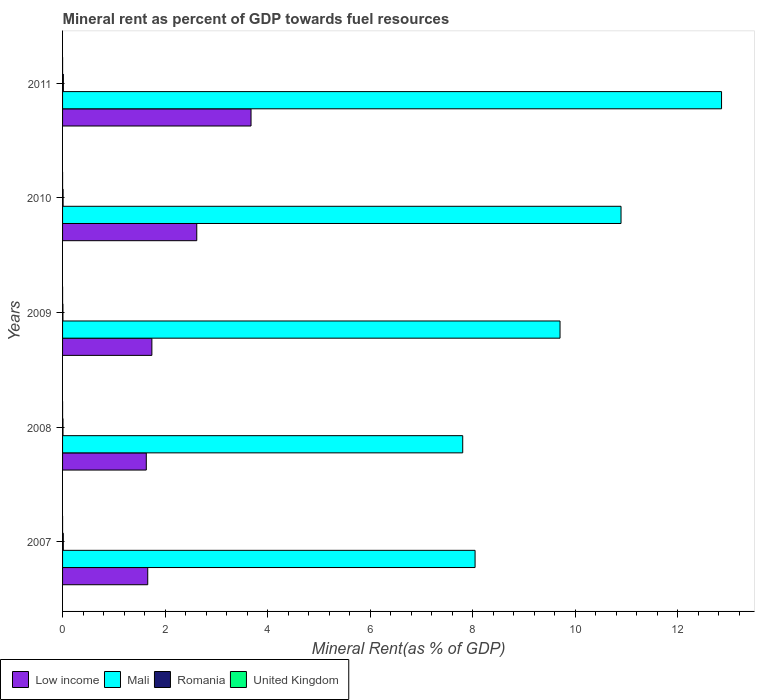How many different coloured bars are there?
Offer a terse response. 4. Are the number of bars on each tick of the Y-axis equal?
Keep it short and to the point. Yes. How many bars are there on the 5th tick from the bottom?
Your answer should be compact. 4. What is the label of the 3rd group of bars from the top?
Offer a terse response. 2009. What is the mineral rent in Low income in 2008?
Ensure brevity in your answer.  1.63. Across all years, what is the maximum mineral rent in Mali?
Keep it short and to the point. 12.86. Across all years, what is the minimum mineral rent in Low income?
Keep it short and to the point. 1.63. In which year was the mineral rent in Romania maximum?
Provide a short and direct response. 2011. What is the total mineral rent in Romania in the graph?
Your answer should be very brief. 0.06. What is the difference between the mineral rent in Romania in 2008 and that in 2011?
Your answer should be compact. -0.01. What is the difference between the mineral rent in Low income in 2010 and the mineral rent in Mali in 2011?
Give a very brief answer. -10.24. What is the average mineral rent in Romania per year?
Provide a succinct answer. 0.01. In the year 2009, what is the difference between the mineral rent in Romania and mineral rent in Mali?
Offer a very short reply. -9.7. What is the ratio of the mineral rent in Romania in 2010 to that in 2011?
Provide a succinct answer. 0.67. What is the difference between the highest and the second highest mineral rent in Mali?
Give a very brief answer. 1.96. What is the difference between the highest and the lowest mineral rent in Mali?
Keep it short and to the point. 5.05. Is the sum of the mineral rent in Low income in 2010 and 2011 greater than the maximum mineral rent in Mali across all years?
Ensure brevity in your answer.  No. What does the 2nd bar from the top in 2010 represents?
Keep it short and to the point. Romania. What does the 3rd bar from the bottom in 2010 represents?
Keep it short and to the point. Romania. Is it the case that in every year, the sum of the mineral rent in Mali and mineral rent in Romania is greater than the mineral rent in Low income?
Provide a short and direct response. Yes. Are all the bars in the graph horizontal?
Offer a very short reply. Yes. How many years are there in the graph?
Ensure brevity in your answer.  5. Does the graph contain any zero values?
Provide a succinct answer. No. Where does the legend appear in the graph?
Keep it short and to the point. Bottom left. How many legend labels are there?
Give a very brief answer. 4. What is the title of the graph?
Provide a succinct answer. Mineral rent as percent of GDP towards fuel resources. What is the label or title of the X-axis?
Provide a succinct answer. Mineral Rent(as % of GDP). What is the Mineral Rent(as % of GDP) of Low income in 2007?
Make the answer very short. 1.66. What is the Mineral Rent(as % of GDP) of Mali in 2007?
Offer a very short reply. 8.05. What is the Mineral Rent(as % of GDP) in Romania in 2007?
Give a very brief answer. 0.01. What is the Mineral Rent(as % of GDP) in United Kingdom in 2007?
Your answer should be compact. 3.21125777650235e-5. What is the Mineral Rent(as % of GDP) of Low income in 2008?
Make the answer very short. 1.63. What is the Mineral Rent(as % of GDP) of Mali in 2008?
Your response must be concise. 7.81. What is the Mineral Rent(as % of GDP) in Romania in 2008?
Your answer should be very brief. 0.01. What is the Mineral Rent(as % of GDP) of United Kingdom in 2008?
Your response must be concise. 0. What is the Mineral Rent(as % of GDP) of Low income in 2009?
Make the answer very short. 1.74. What is the Mineral Rent(as % of GDP) in Mali in 2009?
Your response must be concise. 9.71. What is the Mineral Rent(as % of GDP) in Romania in 2009?
Your response must be concise. 0.01. What is the Mineral Rent(as % of GDP) in United Kingdom in 2009?
Offer a very short reply. 0. What is the Mineral Rent(as % of GDP) of Low income in 2010?
Keep it short and to the point. 2.62. What is the Mineral Rent(as % of GDP) in Mali in 2010?
Offer a terse response. 10.9. What is the Mineral Rent(as % of GDP) of Romania in 2010?
Give a very brief answer. 0.01. What is the Mineral Rent(as % of GDP) of United Kingdom in 2010?
Offer a terse response. 0. What is the Mineral Rent(as % of GDP) of Low income in 2011?
Ensure brevity in your answer.  3.68. What is the Mineral Rent(as % of GDP) of Mali in 2011?
Your answer should be very brief. 12.86. What is the Mineral Rent(as % of GDP) in Romania in 2011?
Give a very brief answer. 0.02. What is the Mineral Rent(as % of GDP) of United Kingdom in 2011?
Keep it short and to the point. 0. Across all years, what is the maximum Mineral Rent(as % of GDP) in Low income?
Offer a very short reply. 3.68. Across all years, what is the maximum Mineral Rent(as % of GDP) of Mali?
Offer a very short reply. 12.86. Across all years, what is the maximum Mineral Rent(as % of GDP) of Romania?
Ensure brevity in your answer.  0.02. Across all years, what is the maximum Mineral Rent(as % of GDP) in United Kingdom?
Your response must be concise. 0. Across all years, what is the minimum Mineral Rent(as % of GDP) of Low income?
Your answer should be very brief. 1.63. Across all years, what is the minimum Mineral Rent(as % of GDP) of Mali?
Provide a short and direct response. 7.81. Across all years, what is the minimum Mineral Rent(as % of GDP) of Romania?
Make the answer very short. 0.01. Across all years, what is the minimum Mineral Rent(as % of GDP) of United Kingdom?
Your answer should be compact. 3.21125777650235e-5. What is the total Mineral Rent(as % of GDP) in Low income in the graph?
Provide a succinct answer. 11.33. What is the total Mineral Rent(as % of GDP) of Mali in the graph?
Provide a short and direct response. 49.32. What is the total Mineral Rent(as % of GDP) in Romania in the graph?
Provide a short and direct response. 0.06. What is the total Mineral Rent(as % of GDP) of United Kingdom in the graph?
Offer a very short reply. 0. What is the difference between the Mineral Rent(as % of GDP) in Low income in 2007 and that in 2008?
Provide a short and direct response. 0.03. What is the difference between the Mineral Rent(as % of GDP) of Mali in 2007 and that in 2008?
Make the answer very short. 0.24. What is the difference between the Mineral Rent(as % of GDP) of Romania in 2007 and that in 2008?
Provide a succinct answer. 0.01. What is the difference between the Mineral Rent(as % of GDP) of United Kingdom in 2007 and that in 2008?
Your response must be concise. -0. What is the difference between the Mineral Rent(as % of GDP) in Low income in 2007 and that in 2009?
Provide a short and direct response. -0.08. What is the difference between the Mineral Rent(as % of GDP) in Mali in 2007 and that in 2009?
Provide a succinct answer. -1.66. What is the difference between the Mineral Rent(as % of GDP) in Romania in 2007 and that in 2009?
Give a very brief answer. 0.01. What is the difference between the Mineral Rent(as % of GDP) of United Kingdom in 2007 and that in 2009?
Give a very brief answer. -0. What is the difference between the Mineral Rent(as % of GDP) of Low income in 2007 and that in 2010?
Offer a very short reply. -0.96. What is the difference between the Mineral Rent(as % of GDP) in Mali in 2007 and that in 2010?
Give a very brief answer. -2.85. What is the difference between the Mineral Rent(as % of GDP) in Romania in 2007 and that in 2010?
Make the answer very short. 0. What is the difference between the Mineral Rent(as % of GDP) in United Kingdom in 2007 and that in 2010?
Provide a short and direct response. -0. What is the difference between the Mineral Rent(as % of GDP) of Low income in 2007 and that in 2011?
Provide a short and direct response. -2.02. What is the difference between the Mineral Rent(as % of GDP) in Mali in 2007 and that in 2011?
Ensure brevity in your answer.  -4.81. What is the difference between the Mineral Rent(as % of GDP) of Romania in 2007 and that in 2011?
Keep it short and to the point. -0. What is the difference between the Mineral Rent(as % of GDP) of United Kingdom in 2007 and that in 2011?
Offer a terse response. -0. What is the difference between the Mineral Rent(as % of GDP) in Low income in 2008 and that in 2009?
Keep it short and to the point. -0.11. What is the difference between the Mineral Rent(as % of GDP) in Mali in 2008 and that in 2009?
Your answer should be very brief. -1.9. What is the difference between the Mineral Rent(as % of GDP) in Romania in 2008 and that in 2009?
Offer a very short reply. 0. What is the difference between the Mineral Rent(as % of GDP) in United Kingdom in 2008 and that in 2009?
Give a very brief answer. -0. What is the difference between the Mineral Rent(as % of GDP) in Low income in 2008 and that in 2010?
Keep it short and to the point. -0.98. What is the difference between the Mineral Rent(as % of GDP) in Mali in 2008 and that in 2010?
Your answer should be very brief. -3.09. What is the difference between the Mineral Rent(as % of GDP) of Romania in 2008 and that in 2010?
Provide a short and direct response. -0. What is the difference between the Mineral Rent(as % of GDP) of United Kingdom in 2008 and that in 2010?
Offer a very short reply. -0. What is the difference between the Mineral Rent(as % of GDP) in Low income in 2008 and that in 2011?
Provide a succinct answer. -2.04. What is the difference between the Mineral Rent(as % of GDP) in Mali in 2008 and that in 2011?
Give a very brief answer. -5.05. What is the difference between the Mineral Rent(as % of GDP) in Romania in 2008 and that in 2011?
Keep it short and to the point. -0.01. What is the difference between the Mineral Rent(as % of GDP) in United Kingdom in 2008 and that in 2011?
Your response must be concise. -0. What is the difference between the Mineral Rent(as % of GDP) in Low income in 2009 and that in 2010?
Your answer should be very brief. -0.88. What is the difference between the Mineral Rent(as % of GDP) in Mali in 2009 and that in 2010?
Give a very brief answer. -1.19. What is the difference between the Mineral Rent(as % of GDP) of Romania in 2009 and that in 2010?
Your response must be concise. -0. What is the difference between the Mineral Rent(as % of GDP) of United Kingdom in 2009 and that in 2010?
Ensure brevity in your answer.  -0. What is the difference between the Mineral Rent(as % of GDP) of Low income in 2009 and that in 2011?
Give a very brief answer. -1.93. What is the difference between the Mineral Rent(as % of GDP) of Mali in 2009 and that in 2011?
Offer a terse response. -3.15. What is the difference between the Mineral Rent(as % of GDP) of Romania in 2009 and that in 2011?
Your answer should be very brief. -0.01. What is the difference between the Mineral Rent(as % of GDP) in United Kingdom in 2009 and that in 2011?
Keep it short and to the point. -0. What is the difference between the Mineral Rent(as % of GDP) of Low income in 2010 and that in 2011?
Provide a succinct answer. -1.06. What is the difference between the Mineral Rent(as % of GDP) in Mali in 2010 and that in 2011?
Your response must be concise. -1.96. What is the difference between the Mineral Rent(as % of GDP) of Romania in 2010 and that in 2011?
Offer a very short reply. -0.01. What is the difference between the Mineral Rent(as % of GDP) in United Kingdom in 2010 and that in 2011?
Offer a terse response. -0. What is the difference between the Mineral Rent(as % of GDP) of Low income in 2007 and the Mineral Rent(as % of GDP) of Mali in 2008?
Make the answer very short. -6.15. What is the difference between the Mineral Rent(as % of GDP) in Low income in 2007 and the Mineral Rent(as % of GDP) in Romania in 2008?
Your answer should be compact. 1.65. What is the difference between the Mineral Rent(as % of GDP) of Low income in 2007 and the Mineral Rent(as % of GDP) of United Kingdom in 2008?
Provide a short and direct response. 1.66. What is the difference between the Mineral Rent(as % of GDP) of Mali in 2007 and the Mineral Rent(as % of GDP) of Romania in 2008?
Provide a succinct answer. 8.04. What is the difference between the Mineral Rent(as % of GDP) in Mali in 2007 and the Mineral Rent(as % of GDP) in United Kingdom in 2008?
Provide a short and direct response. 8.05. What is the difference between the Mineral Rent(as % of GDP) in Romania in 2007 and the Mineral Rent(as % of GDP) in United Kingdom in 2008?
Offer a very short reply. 0.01. What is the difference between the Mineral Rent(as % of GDP) in Low income in 2007 and the Mineral Rent(as % of GDP) in Mali in 2009?
Ensure brevity in your answer.  -8.05. What is the difference between the Mineral Rent(as % of GDP) of Low income in 2007 and the Mineral Rent(as % of GDP) of Romania in 2009?
Your response must be concise. 1.65. What is the difference between the Mineral Rent(as % of GDP) of Low income in 2007 and the Mineral Rent(as % of GDP) of United Kingdom in 2009?
Ensure brevity in your answer.  1.66. What is the difference between the Mineral Rent(as % of GDP) of Mali in 2007 and the Mineral Rent(as % of GDP) of Romania in 2009?
Your answer should be compact. 8.04. What is the difference between the Mineral Rent(as % of GDP) in Mali in 2007 and the Mineral Rent(as % of GDP) in United Kingdom in 2009?
Ensure brevity in your answer.  8.05. What is the difference between the Mineral Rent(as % of GDP) in Romania in 2007 and the Mineral Rent(as % of GDP) in United Kingdom in 2009?
Make the answer very short. 0.01. What is the difference between the Mineral Rent(as % of GDP) of Low income in 2007 and the Mineral Rent(as % of GDP) of Mali in 2010?
Provide a succinct answer. -9.24. What is the difference between the Mineral Rent(as % of GDP) of Low income in 2007 and the Mineral Rent(as % of GDP) of Romania in 2010?
Provide a short and direct response. 1.65. What is the difference between the Mineral Rent(as % of GDP) in Low income in 2007 and the Mineral Rent(as % of GDP) in United Kingdom in 2010?
Make the answer very short. 1.66. What is the difference between the Mineral Rent(as % of GDP) of Mali in 2007 and the Mineral Rent(as % of GDP) of Romania in 2010?
Offer a terse response. 8.04. What is the difference between the Mineral Rent(as % of GDP) of Mali in 2007 and the Mineral Rent(as % of GDP) of United Kingdom in 2010?
Provide a succinct answer. 8.05. What is the difference between the Mineral Rent(as % of GDP) of Romania in 2007 and the Mineral Rent(as % of GDP) of United Kingdom in 2010?
Make the answer very short. 0.01. What is the difference between the Mineral Rent(as % of GDP) of Low income in 2007 and the Mineral Rent(as % of GDP) of Mali in 2011?
Offer a very short reply. -11.2. What is the difference between the Mineral Rent(as % of GDP) of Low income in 2007 and the Mineral Rent(as % of GDP) of Romania in 2011?
Offer a terse response. 1.65. What is the difference between the Mineral Rent(as % of GDP) in Low income in 2007 and the Mineral Rent(as % of GDP) in United Kingdom in 2011?
Offer a terse response. 1.66. What is the difference between the Mineral Rent(as % of GDP) in Mali in 2007 and the Mineral Rent(as % of GDP) in Romania in 2011?
Your response must be concise. 8.03. What is the difference between the Mineral Rent(as % of GDP) of Mali in 2007 and the Mineral Rent(as % of GDP) of United Kingdom in 2011?
Provide a short and direct response. 8.05. What is the difference between the Mineral Rent(as % of GDP) of Romania in 2007 and the Mineral Rent(as % of GDP) of United Kingdom in 2011?
Offer a terse response. 0.01. What is the difference between the Mineral Rent(as % of GDP) in Low income in 2008 and the Mineral Rent(as % of GDP) in Mali in 2009?
Give a very brief answer. -8.07. What is the difference between the Mineral Rent(as % of GDP) of Low income in 2008 and the Mineral Rent(as % of GDP) of Romania in 2009?
Give a very brief answer. 1.63. What is the difference between the Mineral Rent(as % of GDP) in Low income in 2008 and the Mineral Rent(as % of GDP) in United Kingdom in 2009?
Keep it short and to the point. 1.63. What is the difference between the Mineral Rent(as % of GDP) in Mali in 2008 and the Mineral Rent(as % of GDP) in Romania in 2009?
Provide a succinct answer. 7.8. What is the difference between the Mineral Rent(as % of GDP) in Mali in 2008 and the Mineral Rent(as % of GDP) in United Kingdom in 2009?
Offer a very short reply. 7.81. What is the difference between the Mineral Rent(as % of GDP) of Romania in 2008 and the Mineral Rent(as % of GDP) of United Kingdom in 2009?
Ensure brevity in your answer.  0.01. What is the difference between the Mineral Rent(as % of GDP) in Low income in 2008 and the Mineral Rent(as % of GDP) in Mali in 2010?
Offer a terse response. -9.26. What is the difference between the Mineral Rent(as % of GDP) of Low income in 2008 and the Mineral Rent(as % of GDP) of Romania in 2010?
Provide a succinct answer. 1.62. What is the difference between the Mineral Rent(as % of GDP) of Low income in 2008 and the Mineral Rent(as % of GDP) of United Kingdom in 2010?
Ensure brevity in your answer.  1.63. What is the difference between the Mineral Rent(as % of GDP) of Mali in 2008 and the Mineral Rent(as % of GDP) of Romania in 2010?
Your response must be concise. 7.8. What is the difference between the Mineral Rent(as % of GDP) of Mali in 2008 and the Mineral Rent(as % of GDP) of United Kingdom in 2010?
Provide a short and direct response. 7.81. What is the difference between the Mineral Rent(as % of GDP) of Romania in 2008 and the Mineral Rent(as % of GDP) of United Kingdom in 2010?
Offer a very short reply. 0.01. What is the difference between the Mineral Rent(as % of GDP) in Low income in 2008 and the Mineral Rent(as % of GDP) in Mali in 2011?
Make the answer very short. -11.22. What is the difference between the Mineral Rent(as % of GDP) in Low income in 2008 and the Mineral Rent(as % of GDP) in Romania in 2011?
Keep it short and to the point. 1.62. What is the difference between the Mineral Rent(as % of GDP) in Low income in 2008 and the Mineral Rent(as % of GDP) in United Kingdom in 2011?
Ensure brevity in your answer.  1.63. What is the difference between the Mineral Rent(as % of GDP) of Mali in 2008 and the Mineral Rent(as % of GDP) of Romania in 2011?
Make the answer very short. 7.79. What is the difference between the Mineral Rent(as % of GDP) in Mali in 2008 and the Mineral Rent(as % of GDP) in United Kingdom in 2011?
Give a very brief answer. 7.81. What is the difference between the Mineral Rent(as % of GDP) in Romania in 2008 and the Mineral Rent(as % of GDP) in United Kingdom in 2011?
Ensure brevity in your answer.  0.01. What is the difference between the Mineral Rent(as % of GDP) of Low income in 2009 and the Mineral Rent(as % of GDP) of Mali in 2010?
Your response must be concise. -9.15. What is the difference between the Mineral Rent(as % of GDP) in Low income in 2009 and the Mineral Rent(as % of GDP) in Romania in 2010?
Provide a short and direct response. 1.73. What is the difference between the Mineral Rent(as % of GDP) in Low income in 2009 and the Mineral Rent(as % of GDP) in United Kingdom in 2010?
Offer a terse response. 1.74. What is the difference between the Mineral Rent(as % of GDP) in Mali in 2009 and the Mineral Rent(as % of GDP) in Romania in 2010?
Provide a succinct answer. 9.7. What is the difference between the Mineral Rent(as % of GDP) in Mali in 2009 and the Mineral Rent(as % of GDP) in United Kingdom in 2010?
Offer a terse response. 9.71. What is the difference between the Mineral Rent(as % of GDP) in Romania in 2009 and the Mineral Rent(as % of GDP) in United Kingdom in 2010?
Offer a very short reply. 0.01. What is the difference between the Mineral Rent(as % of GDP) of Low income in 2009 and the Mineral Rent(as % of GDP) of Mali in 2011?
Ensure brevity in your answer.  -11.12. What is the difference between the Mineral Rent(as % of GDP) in Low income in 2009 and the Mineral Rent(as % of GDP) in Romania in 2011?
Your response must be concise. 1.73. What is the difference between the Mineral Rent(as % of GDP) of Low income in 2009 and the Mineral Rent(as % of GDP) of United Kingdom in 2011?
Your answer should be very brief. 1.74. What is the difference between the Mineral Rent(as % of GDP) in Mali in 2009 and the Mineral Rent(as % of GDP) in Romania in 2011?
Your answer should be very brief. 9.69. What is the difference between the Mineral Rent(as % of GDP) in Mali in 2009 and the Mineral Rent(as % of GDP) in United Kingdom in 2011?
Your answer should be compact. 9.71. What is the difference between the Mineral Rent(as % of GDP) of Romania in 2009 and the Mineral Rent(as % of GDP) of United Kingdom in 2011?
Your answer should be very brief. 0.01. What is the difference between the Mineral Rent(as % of GDP) in Low income in 2010 and the Mineral Rent(as % of GDP) in Mali in 2011?
Offer a very short reply. -10.24. What is the difference between the Mineral Rent(as % of GDP) in Low income in 2010 and the Mineral Rent(as % of GDP) in Romania in 2011?
Your answer should be compact. 2.6. What is the difference between the Mineral Rent(as % of GDP) in Low income in 2010 and the Mineral Rent(as % of GDP) in United Kingdom in 2011?
Provide a succinct answer. 2.62. What is the difference between the Mineral Rent(as % of GDP) in Mali in 2010 and the Mineral Rent(as % of GDP) in Romania in 2011?
Make the answer very short. 10.88. What is the difference between the Mineral Rent(as % of GDP) in Mali in 2010 and the Mineral Rent(as % of GDP) in United Kingdom in 2011?
Provide a short and direct response. 10.9. What is the difference between the Mineral Rent(as % of GDP) of Romania in 2010 and the Mineral Rent(as % of GDP) of United Kingdom in 2011?
Keep it short and to the point. 0.01. What is the average Mineral Rent(as % of GDP) of Low income per year?
Make the answer very short. 2.27. What is the average Mineral Rent(as % of GDP) in Mali per year?
Make the answer very short. 9.86. What is the average Mineral Rent(as % of GDP) in Romania per year?
Your response must be concise. 0.01. In the year 2007, what is the difference between the Mineral Rent(as % of GDP) in Low income and Mineral Rent(as % of GDP) in Mali?
Offer a terse response. -6.39. In the year 2007, what is the difference between the Mineral Rent(as % of GDP) of Low income and Mineral Rent(as % of GDP) of Romania?
Ensure brevity in your answer.  1.65. In the year 2007, what is the difference between the Mineral Rent(as % of GDP) in Low income and Mineral Rent(as % of GDP) in United Kingdom?
Offer a terse response. 1.66. In the year 2007, what is the difference between the Mineral Rent(as % of GDP) of Mali and Mineral Rent(as % of GDP) of Romania?
Offer a very short reply. 8.04. In the year 2007, what is the difference between the Mineral Rent(as % of GDP) in Mali and Mineral Rent(as % of GDP) in United Kingdom?
Keep it short and to the point. 8.05. In the year 2007, what is the difference between the Mineral Rent(as % of GDP) of Romania and Mineral Rent(as % of GDP) of United Kingdom?
Your answer should be very brief. 0.01. In the year 2008, what is the difference between the Mineral Rent(as % of GDP) in Low income and Mineral Rent(as % of GDP) in Mali?
Offer a terse response. -6.17. In the year 2008, what is the difference between the Mineral Rent(as % of GDP) of Low income and Mineral Rent(as % of GDP) of Romania?
Your answer should be compact. 1.63. In the year 2008, what is the difference between the Mineral Rent(as % of GDP) in Low income and Mineral Rent(as % of GDP) in United Kingdom?
Your answer should be compact. 1.63. In the year 2008, what is the difference between the Mineral Rent(as % of GDP) in Mali and Mineral Rent(as % of GDP) in Romania?
Offer a terse response. 7.8. In the year 2008, what is the difference between the Mineral Rent(as % of GDP) of Mali and Mineral Rent(as % of GDP) of United Kingdom?
Your answer should be very brief. 7.81. In the year 2008, what is the difference between the Mineral Rent(as % of GDP) of Romania and Mineral Rent(as % of GDP) of United Kingdom?
Keep it short and to the point. 0.01. In the year 2009, what is the difference between the Mineral Rent(as % of GDP) of Low income and Mineral Rent(as % of GDP) of Mali?
Your response must be concise. -7.96. In the year 2009, what is the difference between the Mineral Rent(as % of GDP) in Low income and Mineral Rent(as % of GDP) in Romania?
Keep it short and to the point. 1.74. In the year 2009, what is the difference between the Mineral Rent(as % of GDP) in Low income and Mineral Rent(as % of GDP) in United Kingdom?
Make the answer very short. 1.74. In the year 2009, what is the difference between the Mineral Rent(as % of GDP) in Mali and Mineral Rent(as % of GDP) in Romania?
Your response must be concise. 9.7. In the year 2009, what is the difference between the Mineral Rent(as % of GDP) of Mali and Mineral Rent(as % of GDP) of United Kingdom?
Ensure brevity in your answer.  9.71. In the year 2009, what is the difference between the Mineral Rent(as % of GDP) of Romania and Mineral Rent(as % of GDP) of United Kingdom?
Ensure brevity in your answer.  0.01. In the year 2010, what is the difference between the Mineral Rent(as % of GDP) in Low income and Mineral Rent(as % of GDP) in Mali?
Offer a terse response. -8.28. In the year 2010, what is the difference between the Mineral Rent(as % of GDP) in Low income and Mineral Rent(as % of GDP) in Romania?
Provide a succinct answer. 2.61. In the year 2010, what is the difference between the Mineral Rent(as % of GDP) in Low income and Mineral Rent(as % of GDP) in United Kingdom?
Make the answer very short. 2.62. In the year 2010, what is the difference between the Mineral Rent(as % of GDP) in Mali and Mineral Rent(as % of GDP) in Romania?
Give a very brief answer. 10.89. In the year 2010, what is the difference between the Mineral Rent(as % of GDP) in Mali and Mineral Rent(as % of GDP) in United Kingdom?
Ensure brevity in your answer.  10.9. In the year 2010, what is the difference between the Mineral Rent(as % of GDP) in Romania and Mineral Rent(as % of GDP) in United Kingdom?
Give a very brief answer. 0.01. In the year 2011, what is the difference between the Mineral Rent(as % of GDP) of Low income and Mineral Rent(as % of GDP) of Mali?
Make the answer very short. -9.18. In the year 2011, what is the difference between the Mineral Rent(as % of GDP) of Low income and Mineral Rent(as % of GDP) of Romania?
Keep it short and to the point. 3.66. In the year 2011, what is the difference between the Mineral Rent(as % of GDP) in Low income and Mineral Rent(as % of GDP) in United Kingdom?
Offer a terse response. 3.68. In the year 2011, what is the difference between the Mineral Rent(as % of GDP) of Mali and Mineral Rent(as % of GDP) of Romania?
Ensure brevity in your answer.  12.84. In the year 2011, what is the difference between the Mineral Rent(as % of GDP) of Mali and Mineral Rent(as % of GDP) of United Kingdom?
Offer a very short reply. 12.86. In the year 2011, what is the difference between the Mineral Rent(as % of GDP) in Romania and Mineral Rent(as % of GDP) in United Kingdom?
Provide a succinct answer. 0.02. What is the ratio of the Mineral Rent(as % of GDP) in Low income in 2007 to that in 2008?
Offer a very short reply. 1.02. What is the ratio of the Mineral Rent(as % of GDP) of Mali in 2007 to that in 2008?
Offer a very short reply. 1.03. What is the ratio of the Mineral Rent(as % of GDP) of Romania in 2007 to that in 2008?
Provide a succinct answer. 1.69. What is the ratio of the Mineral Rent(as % of GDP) of United Kingdom in 2007 to that in 2008?
Keep it short and to the point. 0.26. What is the ratio of the Mineral Rent(as % of GDP) of Low income in 2007 to that in 2009?
Offer a terse response. 0.95. What is the ratio of the Mineral Rent(as % of GDP) in Mali in 2007 to that in 2009?
Offer a terse response. 0.83. What is the ratio of the Mineral Rent(as % of GDP) in Romania in 2007 to that in 2009?
Keep it short and to the point. 1.99. What is the ratio of the Mineral Rent(as % of GDP) in United Kingdom in 2007 to that in 2009?
Ensure brevity in your answer.  0.17. What is the ratio of the Mineral Rent(as % of GDP) in Low income in 2007 to that in 2010?
Provide a short and direct response. 0.63. What is the ratio of the Mineral Rent(as % of GDP) in Mali in 2007 to that in 2010?
Make the answer very short. 0.74. What is the ratio of the Mineral Rent(as % of GDP) in Romania in 2007 to that in 2010?
Your answer should be very brief. 1.37. What is the ratio of the Mineral Rent(as % of GDP) of United Kingdom in 2007 to that in 2010?
Your response must be concise. 0.14. What is the ratio of the Mineral Rent(as % of GDP) of Low income in 2007 to that in 2011?
Provide a succinct answer. 0.45. What is the ratio of the Mineral Rent(as % of GDP) of Mali in 2007 to that in 2011?
Provide a succinct answer. 0.63. What is the ratio of the Mineral Rent(as % of GDP) in Romania in 2007 to that in 2011?
Offer a very short reply. 0.92. What is the ratio of the Mineral Rent(as % of GDP) in United Kingdom in 2007 to that in 2011?
Your answer should be very brief. 0.1. What is the ratio of the Mineral Rent(as % of GDP) of Mali in 2008 to that in 2009?
Your answer should be compact. 0.8. What is the ratio of the Mineral Rent(as % of GDP) in Romania in 2008 to that in 2009?
Give a very brief answer. 1.17. What is the ratio of the Mineral Rent(as % of GDP) of United Kingdom in 2008 to that in 2009?
Offer a terse response. 0.65. What is the ratio of the Mineral Rent(as % of GDP) of Low income in 2008 to that in 2010?
Your response must be concise. 0.62. What is the ratio of the Mineral Rent(as % of GDP) in Mali in 2008 to that in 2010?
Ensure brevity in your answer.  0.72. What is the ratio of the Mineral Rent(as % of GDP) in Romania in 2008 to that in 2010?
Your response must be concise. 0.81. What is the ratio of the Mineral Rent(as % of GDP) of United Kingdom in 2008 to that in 2010?
Provide a short and direct response. 0.53. What is the ratio of the Mineral Rent(as % of GDP) in Low income in 2008 to that in 2011?
Provide a short and direct response. 0.44. What is the ratio of the Mineral Rent(as % of GDP) of Mali in 2008 to that in 2011?
Your answer should be compact. 0.61. What is the ratio of the Mineral Rent(as % of GDP) of Romania in 2008 to that in 2011?
Give a very brief answer. 0.54. What is the ratio of the Mineral Rent(as % of GDP) in United Kingdom in 2008 to that in 2011?
Keep it short and to the point. 0.37. What is the ratio of the Mineral Rent(as % of GDP) in Low income in 2009 to that in 2010?
Your answer should be very brief. 0.67. What is the ratio of the Mineral Rent(as % of GDP) of Mali in 2009 to that in 2010?
Make the answer very short. 0.89. What is the ratio of the Mineral Rent(as % of GDP) in Romania in 2009 to that in 2010?
Ensure brevity in your answer.  0.69. What is the ratio of the Mineral Rent(as % of GDP) of United Kingdom in 2009 to that in 2010?
Provide a short and direct response. 0.81. What is the ratio of the Mineral Rent(as % of GDP) of Low income in 2009 to that in 2011?
Offer a terse response. 0.47. What is the ratio of the Mineral Rent(as % of GDP) in Mali in 2009 to that in 2011?
Provide a short and direct response. 0.75. What is the ratio of the Mineral Rent(as % of GDP) of Romania in 2009 to that in 2011?
Offer a very short reply. 0.46. What is the ratio of the Mineral Rent(as % of GDP) in United Kingdom in 2009 to that in 2011?
Provide a succinct answer. 0.57. What is the ratio of the Mineral Rent(as % of GDP) in Low income in 2010 to that in 2011?
Offer a very short reply. 0.71. What is the ratio of the Mineral Rent(as % of GDP) in Mali in 2010 to that in 2011?
Offer a terse response. 0.85. What is the ratio of the Mineral Rent(as % of GDP) of Romania in 2010 to that in 2011?
Your answer should be very brief. 0.67. What is the ratio of the Mineral Rent(as % of GDP) in United Kingdom in 2010 to that in 2011?
Provide a succinct answer. 0.7. What is the difference between the highest and the second highest Mineral Rent(as % of GDP) in Low income?
Make the answer very short. 1.06. What is the difference between the highest and the second highest Mineral Rent(as % of GDP) of Mali?
Your answer should be very brief. 1.96. What is the difference between the highest and the second highest Mineral Rent(as % of GDP) in Romania?
Offer a very short reply. 0. What is the difference between the highest and the second highest Mineral Rent(as % of GDP) of United Kingdom?
Offer a terse response. 0. What is the difference between the highest and the lowest Mineral Rent(as % of GDP) in Low income?
Provide a short and direct response. 2.04. What is the difference between the highest and the lowest Mineral Rent(as % of GDP) in Mali?
Your answer should be compact. 5.05. What is the difference between the highest and the lowest Mineral Rent(as % of GDP) of Romania?
Offer a very short reply. 0.01. What is the difference between the highest and the lowest Mineral Rent(as % of GDP) of United Kingdom?
Make the answer very short. 0. 